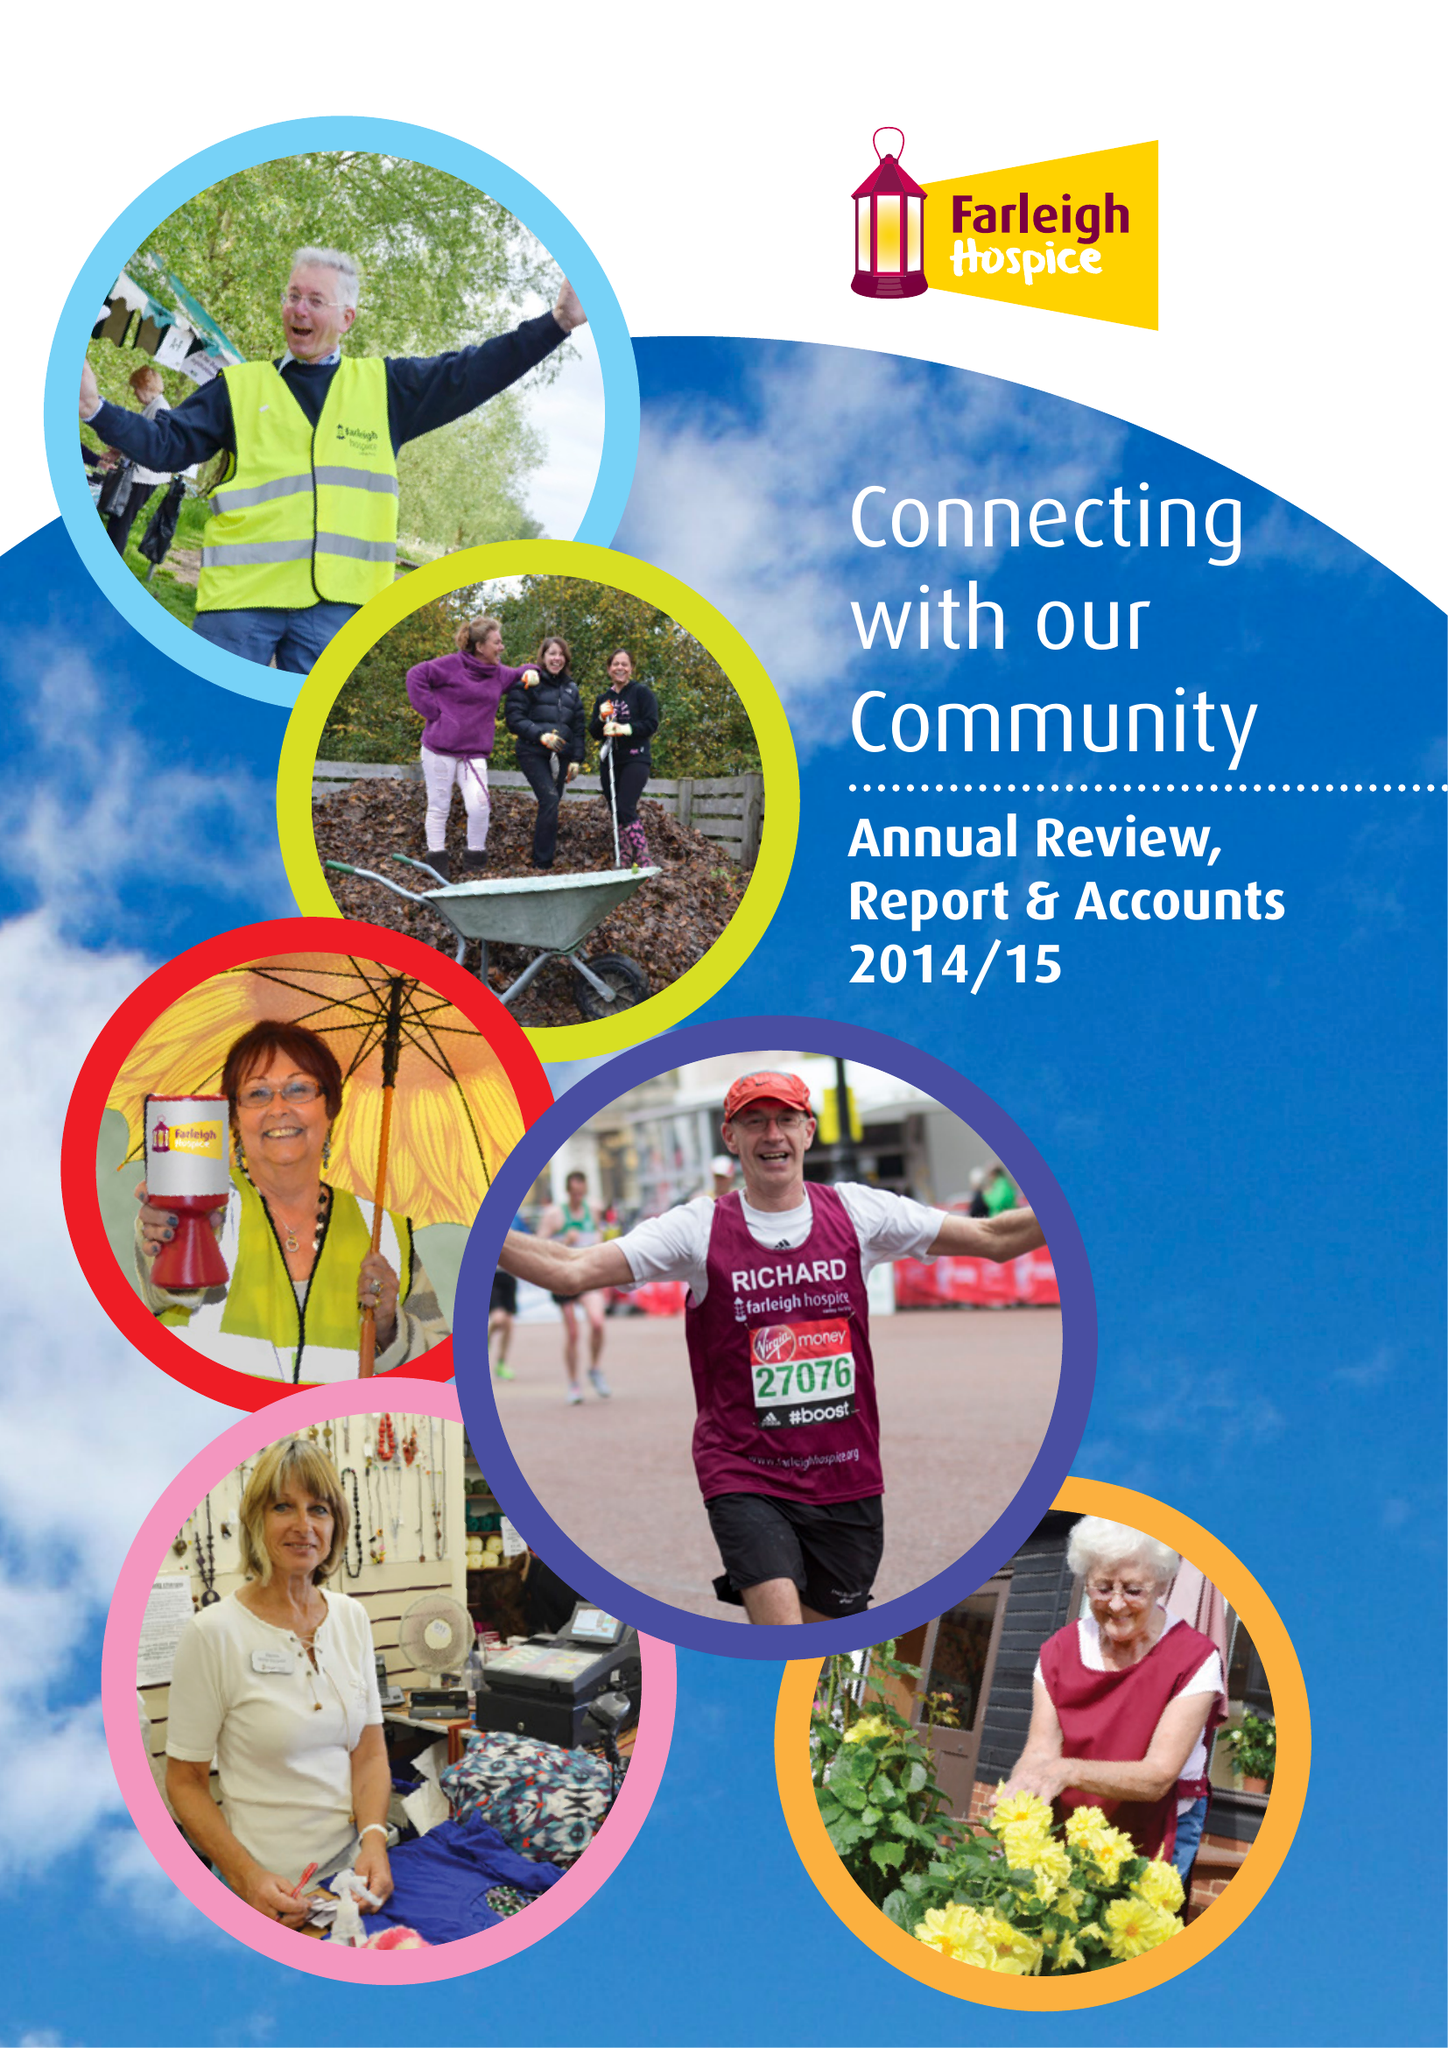What is the value for the charity_number?
Answer the question using a single word or phrase. 284670 